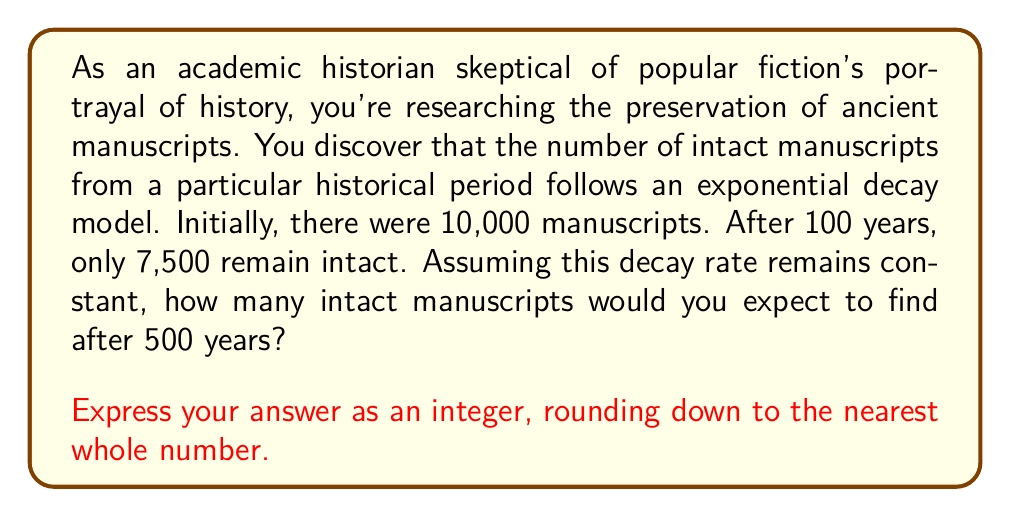Provide a solution to this math problem. Let's approach this step-by-step using the exponential decay formula:

1) The general form of exponential decay is:
   $$ N(t) = N_0 \cdot e^{-\lambda t} $$
   where $N(t)$ is the quantity at time $t$, $N_0$ is the initial quantity, $\lambda$ is the decay constant, and $t$ is time.

2) We know:
   $N_0 = 10,000$ (initial number of manuscripts)
   $N(100) = 7,500$ (after 100 years)
   We need to find $N(500)$

3) First, let's find $\lambda$ using the given information:
   $$ 7,500 = 10,000 \cdot e^{-\lambda \cdot 100} $$

4) Dividing both sides by 10,000:
   $$ 0.75 = e^{-100\lambda} $$

5) Taking natural log of both sides:
   $$ \ln(0.75) = -100\lambda $$

6) Solving for $\lambda$:
   $$ \lambda = -\frac{\ln(0.75)}{100} \approx 0.002877 $$

7) Now we can use this $\lambda$ to find $N(500)$:
   $$ N(500) = 10,000 \cdot e^{-0.002877 \cdot 500} $$

8) Calculating this:
   $$ N(500) \approx 10,000 \cdot e^{-1.4385} \approx 2,373.7646... $$

9) Rounding down to the nearest whole number:
   $N(500) = 2,373$

This exponential decay model provides a mathematical representation of how manuscripts deteriorate over time, which is crucial for understanding the challenges in preserving historical documents.
Answer: 2,373 